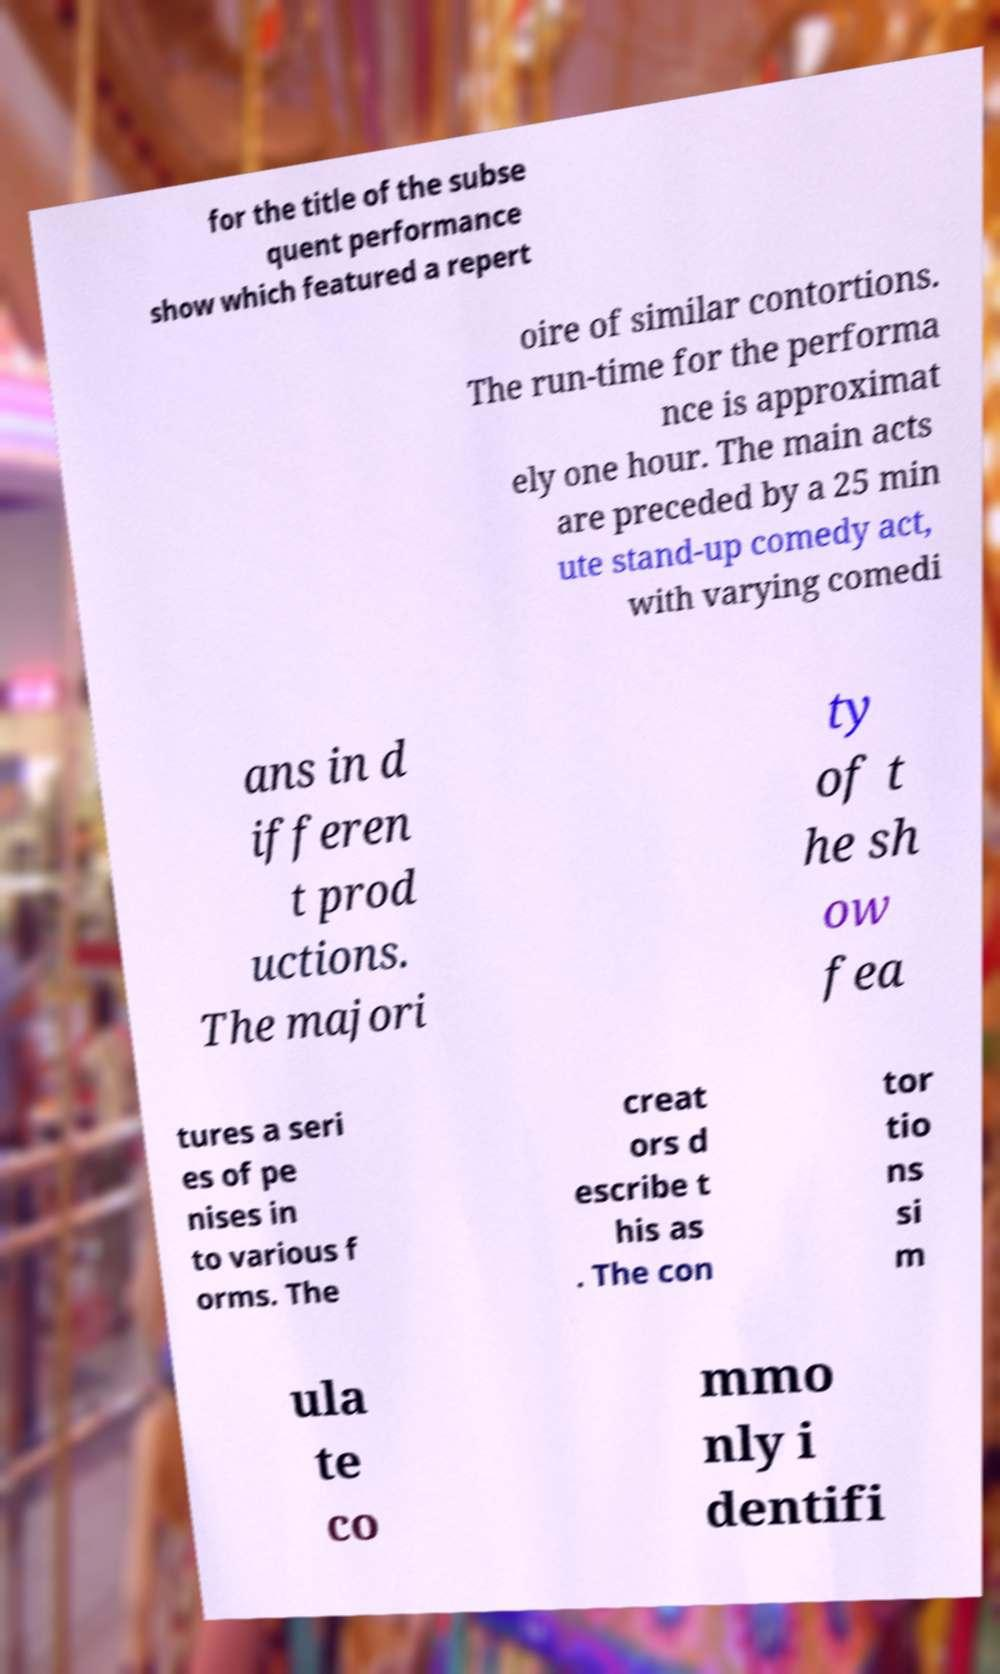Could you assist in decoding the text presented in this image and type it out clearly? for the title of the subse quent performance show which featured a repert oire of similar contortions. The run-time for the performa nce is approximat ely one hour. The main acts are preceded by a 25 min ute stand-up comedy act, with varying comedi ans in d ifferen t prod uctions. The majori ty of t he sh ow fea tures a seri es of pe nises in to various f orms. The creat ors d escribe t his as . The con tor tio ns si m ula te co mmo nly i dentifi 